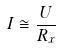<formula> <loc_0><loc_0><loc_500><loc_500>I \cong \frac { U } { R _ { x } }</formula> 